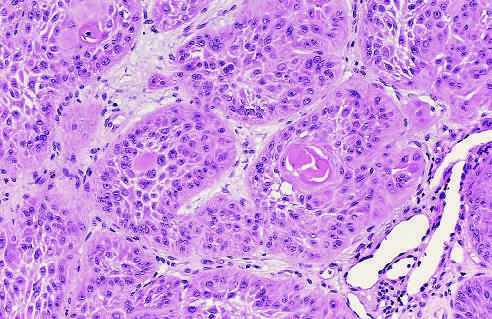re the tumor cells strikingly similar to normal squamous epithelial cells, with intercellular bridges and nests of keratin?
Answer the question using a single word or phrase. Yes 